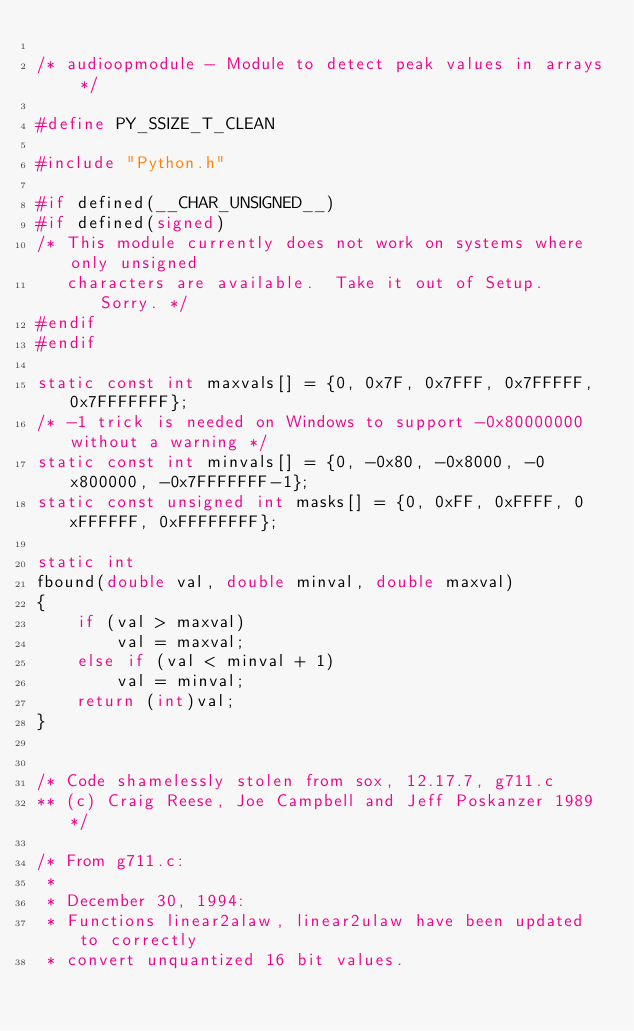Convert code to text. <code><loc_0><loc_0><loc_500><loc_500><_C_>
/* audioopmodule - Module to detect peak values in arrays */

#define PY_SSIZE_T_CLEAN

#include "Python.h"

#if defined(__CHAR_UNSIGNED__)
#if defined(signed)
/* This module currently does not work on systems where only unsigned
   characters are available.  Take it out of Setup.  Sorry. */
#endif
#endif

static const int maxvals[] = {0, 0x7F, 0x7FFF, 0x7FFFFF, 0x7FFFFFFF};
/* -1 trick is needed on Windows to support -0x80000000 without a warning */
static const int minvals[] = {0, -0x80, -0x8000, -0x800000, -0x7FFFFFFF-1};
static const unsigned int masks[] = {0, 0xFF, 0xFFFF, 0xFFFFFF, 0xFFFFFFFF};

static int
fbound(double val, double minval, double maxval)
{
    if (val > maxval)
        val = maxval;
    else if (val < minval + 1)
        val = minval;
    return (int)val;
}


/* Code shamelessly stolen from sox, 12.17.7, g711.c
** (c) Craig Reese, Joe Campbell and Jeff Poskanzer 1989 */

/* From g711.c:
 *
 * December 30, 1994:
 * Functions linear2alaw, linear2ulaw have been updated to correctly
 * convert unquantized 16 bit values.</code> 